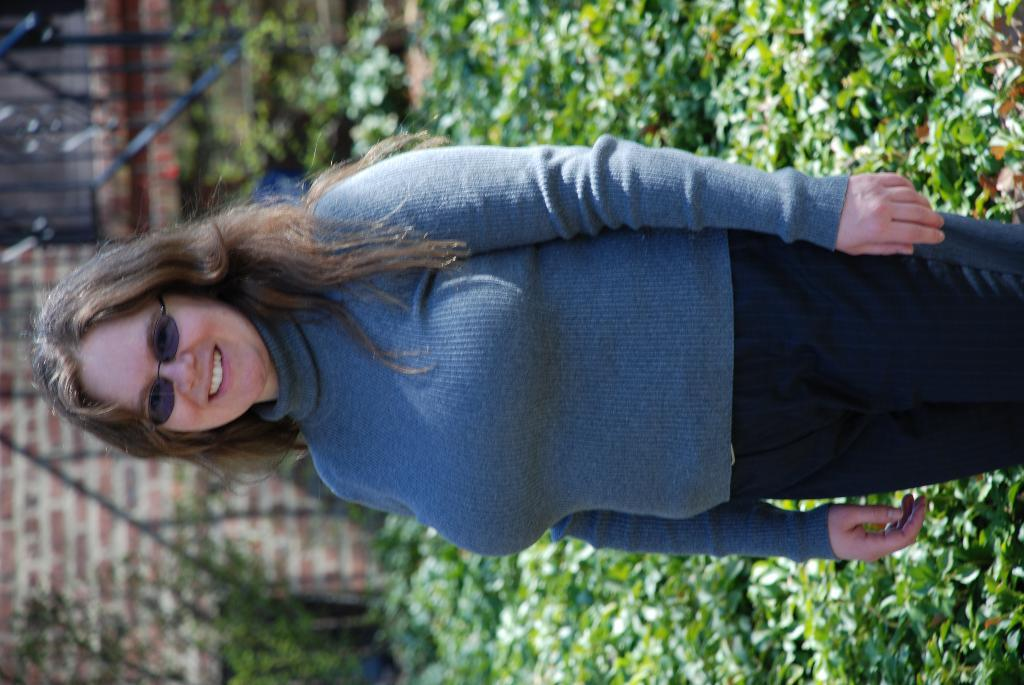What is the main subject of the image? There is a woman standing in the image. What can be seen in the background of the image? There are plants, a grille, and a wall in the background of the image. What type of cracker is being used to fight in the image? There is no fight or cracker present in the image. What type of stew is being prepared in the background of the image? There is no stew or cooking activity depicted in the image. 